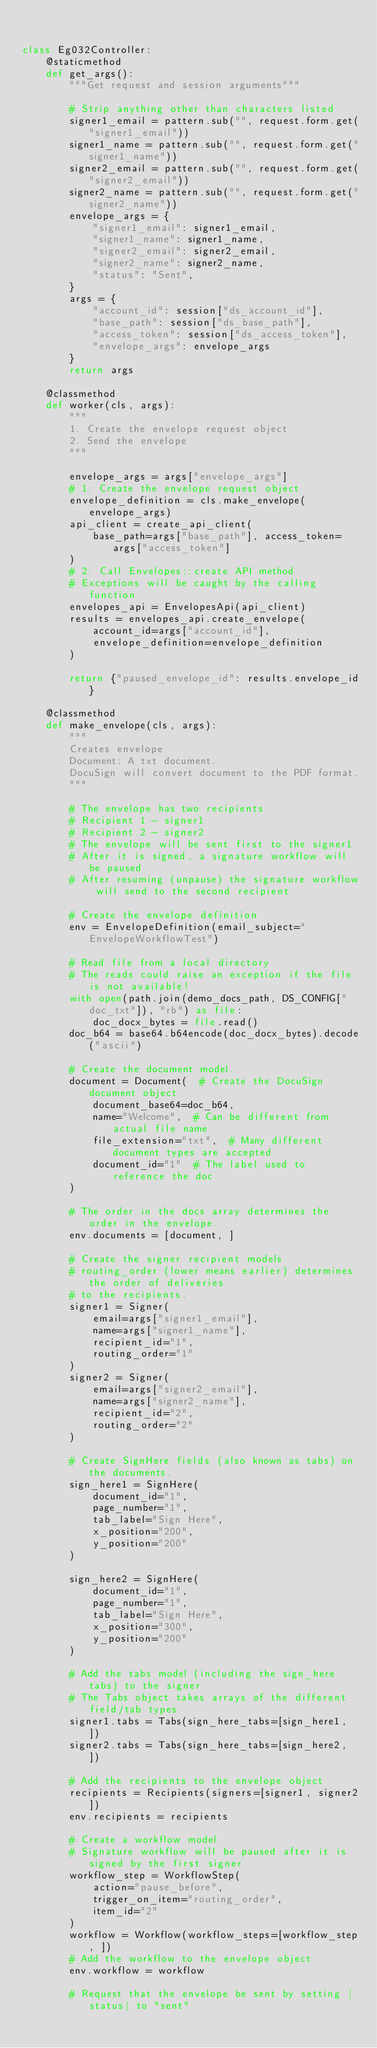Convert code to text. <code><loc_0><loc_0><loc_500><loc_500><_Python_>

class Eg032Controller:
    @staticmethod
    def get_args():
        """Get request and session arguments"""

        # Strip anything other than characters listed
        signer1_email = pattern.sub("", request.form.get("signer1_email"))
        signer1_name = pattern.sub("", request.form.get("signer1_name"))
        signer2_email = pattern.sub("", request.form.get("signer2_email"))
        signer2_name = pattern.sub("", request.form.get("signer2_name"))
        envelope_args = {
            "signer1_email": signer1_email,
            "signer1_name": signer1_name,
            "signer2_email": signer2_email,
            "signer2_name": signer2_name,
            "status": "Sent",
        }
        args = {
            "account_id": session["ds_account_id"],
            "base_path": session["ds_base_path"],
            "access_token": session["ds_access_token"],
            "envelope_args": envelope_args
        }
        return args

    @classmethod
    def worker(cls, args):
        """
        1. Create the envelope request object
        2. Send the envelope
        """

        envelope_args = args["envelope_args"]
        # 1. Create the envelope request object
        envelope_definition = cls.make_envelope(envelope_args)
        api_client = create_api_client(
            base_path=args["base_path"], access_token=args["access_token"]
        )
        # 2. Call Envelopes::create API method
        # Exceptions will be caught by the calling function
        envelopes_api = EnvelopesApi(api_client)
        results = envelopes_api.create_envelope(
            account_id=args["account_id"],
            envelope_definition=envelope_definition
        )

        return {"paused_envelope_id": results.envelope_id}

    @classmethod
    def make_envelope(cls, args):
        """
        Creates envelope
        Document: A txt document.
        DocuSign will convert document to the PDF format.
        """

        # The envelope has two recipients
        # Recipient 1 - signer1
        # Recipient 2 - signer2
        # The envelope will be sent first to the signer1
        # After it is signed, a signature workflow will be paused
        # After resuming (unpause) the signature workflow will send to the second recipient

        # Create the envelope definition
        env = EnvelopeDefinition(email_subject="EnvelopeWorkflowTest")

        # Read file from a local directory
        # The reads could raise an exception if the file is not available!
        with open(path.join(demo_docs_path, DS_CONFIG["doc_txt"]), "rb") as file:
            doc_docx_bytes = file.read()
        doc_b64 = base64.b64encode(doc_docx_bytes).decode("ascii")

        # Create the document model.
        document = Document(  # Create the DocuSign document object
            document_base64=doc_b64,
            name="Welcome",  # Can be different from actual file name
            file_extension="txt",  # Many different document types are accepted
            document_id="1"  # The label used to reference the doc
        )

        # The order in the docs array determines the order in the envelope.
        env.documents = [document, ]

        # Create the signer recipient models
        # routing_order (lower means earlier) determines the order of deliveries
        # to the recipients.
        signer1 = Signer(
            email=args["signer1_email"],
            name=args["signer1_name"],
            recipient_id="1",
            routing_order="1"
        )
        signer2 = Signer(
            email=args["signer2_email"],
            name=args["signer2_name"],
            recipient_id="2",
            routing_order="2"
        )

        # Create SignHere fields (also known as tabs) on the documents.
        sign_here1 = SignHere(
            document_id="1",
            page_number="1",
            tab_label="Sign Here",
            x_position="200",
            y_position="200"
        )

        sign_here2 = SignHere(
            document_id="1",
            page_number="1",
            tab_label="Sign Here",
            x_position="300",
            y_position="200"
        )

        # Add the tabs model (including the sign_here tabs) to the signer
        # The Tabs object takes arrays of the different field/tab types
        signer1.tabs = Tabs(sign_here_tabs=[sign_here1, ])
        signer2.tabs = Tabs(sign_here_tabs=[sign_here2, ])

        # Add the recipients to the envelope object
        recipients = Recipients(signers=[signer1, signer2])
        env.recipients = recipients

        # Create a workflow model
        # Signature workflow will be paused after it is signed by the first signer
        workflow_step = WorkflowStep(
            action="pause_before",
            trigger_on_item="routing_order",
            item_id="2"
        )
        workflow = Workflow(workflow_steps=[workflow_step, ])
        # Add the workflow to the envelope object
        env.workflow = workflow

        # Request that the envelope be sent by setting |status| to "sent"</code> 